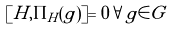<formula> <loc_0><loc_0><loc_500><loc_500>[ H , \Pi _ { H } ( g ) ] = 0 \forall g \in G</formula> 